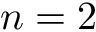<formula> <loc_0><loc_0><loc_500><loc_500>n = 2</formula> 